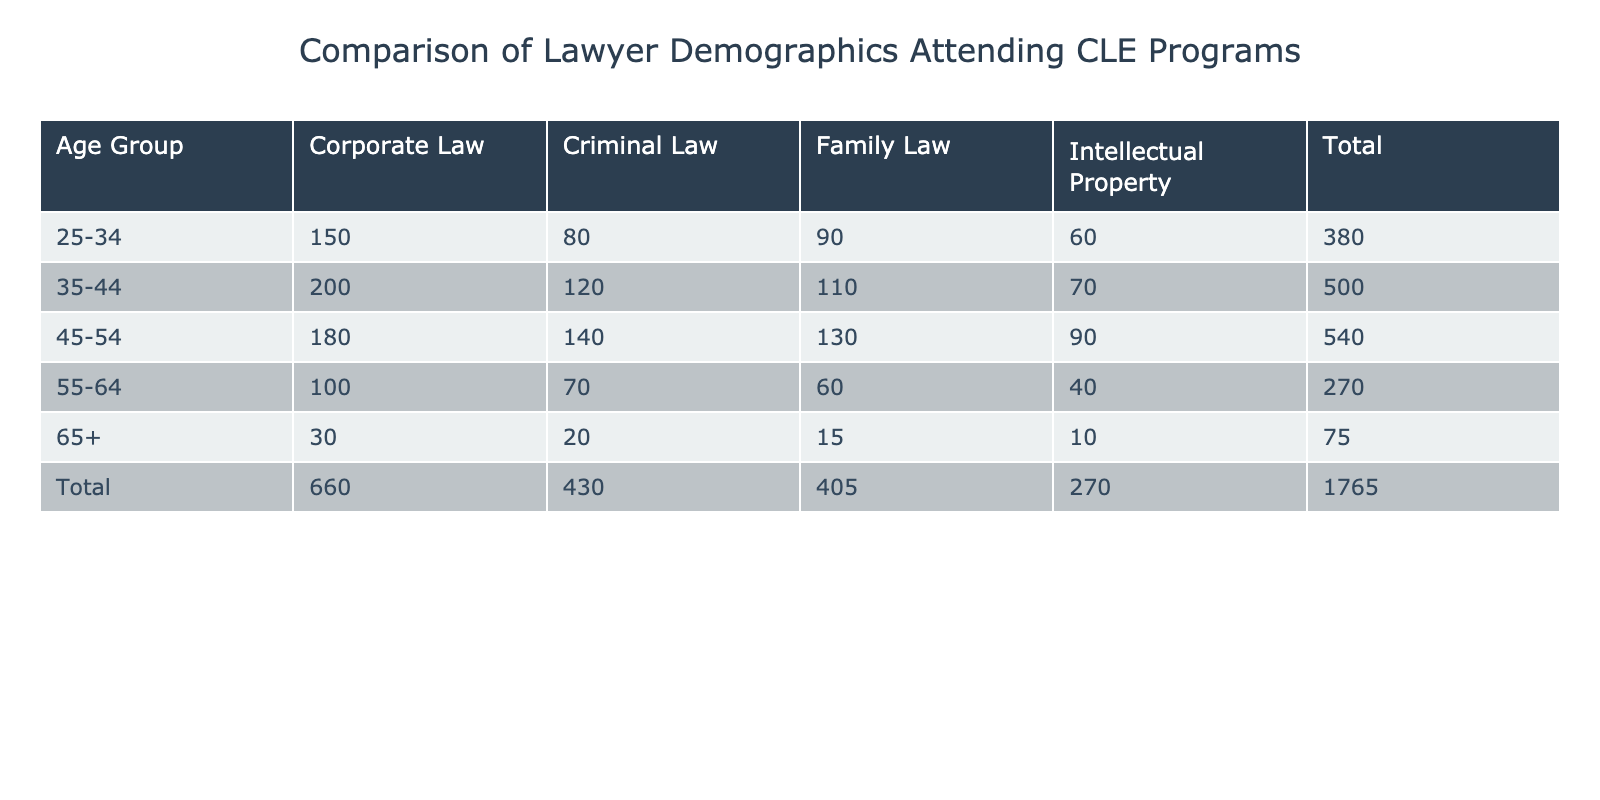What is the total number of attendees in the 25-34 age group? To find the total number of attendees in the 25-34 age group, I look at all the practice areas in that age group: Corporate Law (150), Criminal Law (80), Family Law (90), and Intellectual Property (60). Adding these together: 150 + 80 + 90 + 60 = 380.
Answer: 380 Which legal practice area has the highest number of attendees among those aged 35-44? For the 35-44 age group, I review the number of attendees by practice area: Corporate Law (200), Criminal Law (120), Family Law (110), and Intellectual Property (70). The highest number is in Corporate Law with 200 attendees.
Answer: Corporate Law Is the total number of attendees for the 55-64 age group greater than the total for the 65+ age group? First, I calculate the total for the 55-64 age group: Corporate Law (100), Criminal Law (70), Family Law (60), and Intellectual Property (40), which sums to 270. For the 65+ age group, I sum: Corporate Law (30), Criminal Law (20), Family Law (15), and Intellectual Property (10), which equals 75. Since 270 > 75, the 55-64 age group's total is indeed greater.
Answer: Yes What is the average number of attendees for Criminal Law across all age groups? To find the average number of attendees for Criminal Law, I first identify the numbers from each age group: 80 (25-34), 120 (35-44), 140 (45-54), 70 (55-64), and 20 (65+). I calculate the total for Criminal Law: 80 + 120 + 140 + 70 + 20 = 430. There are 5 age groups, so I divide by 5 to find the average: 430 / 5 = 86.
Answer: 86 Which age group has the lowest attendance in the Family Law practice area? The numbers for Family Law across age groups are: 90 (25-34), 110 (35-44), 130 (45-54), 60 (55-64), and 15 (65+). The lowest attendance is in the 65+ age group with only 15 attendees.
Answer: 65+ 